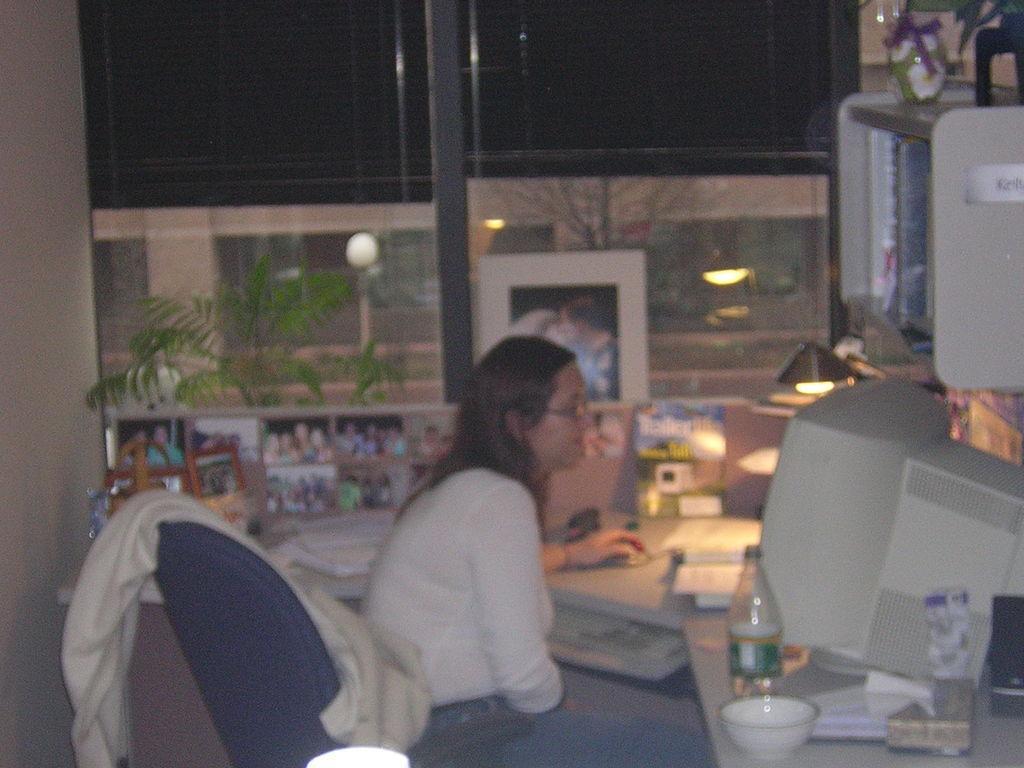Can you describe this image briefly? In this image I see a woman who is sitting on chair and there is a table in front of her on which there are many things. I can also see a window over here. 